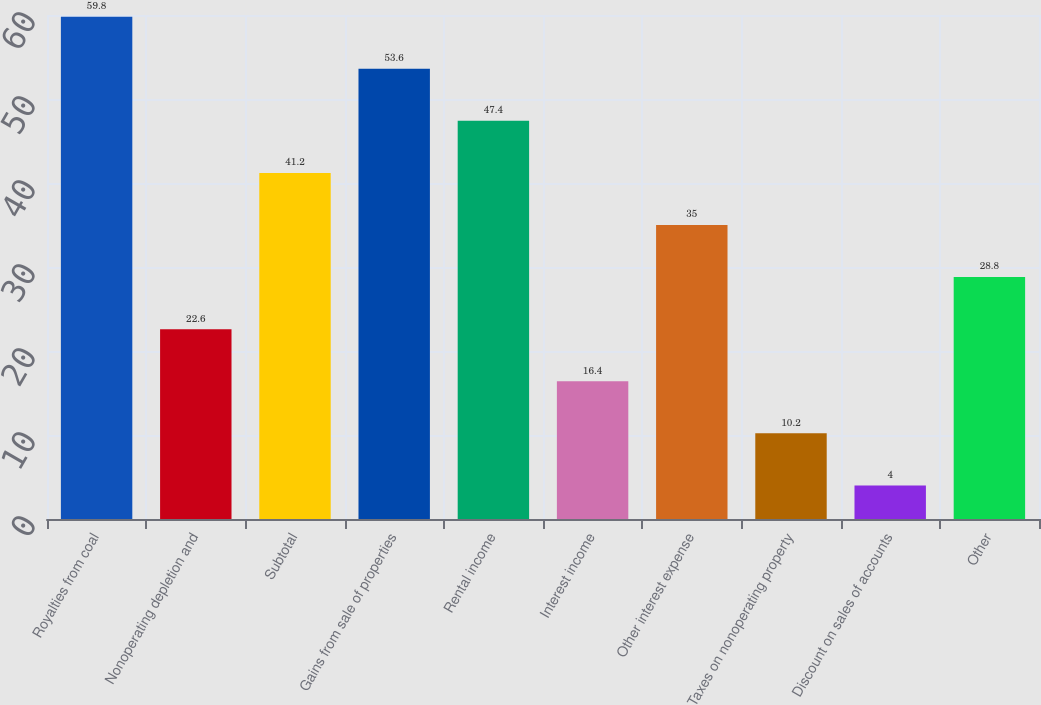Convert chart. <chart><loc_0><loc_0><loc_500><loc_500><bar_chart><fcel>Royalties from coal<fcel>Nonoperating depletion and<fcel>Subtotal<fcel>Gains from sale of properties<fcel>Rental income<fcel>Interest income<fcel>Other interest expense<fcel>Taxes on nonoperating property<fcel>Discount on sales of accounts<fcel>Other<nl><fcel>59.8<fcel>22.6<fcel>41.2<fcel>53.6<fcel>47.4<fcel>16.4<fcel>35<fcel>10.2<fcel>4<fcel>28.8<nl></chart> 